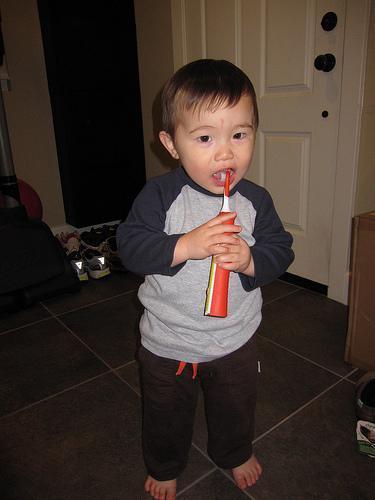How many people are there?
Give a very brief answer. 1. 